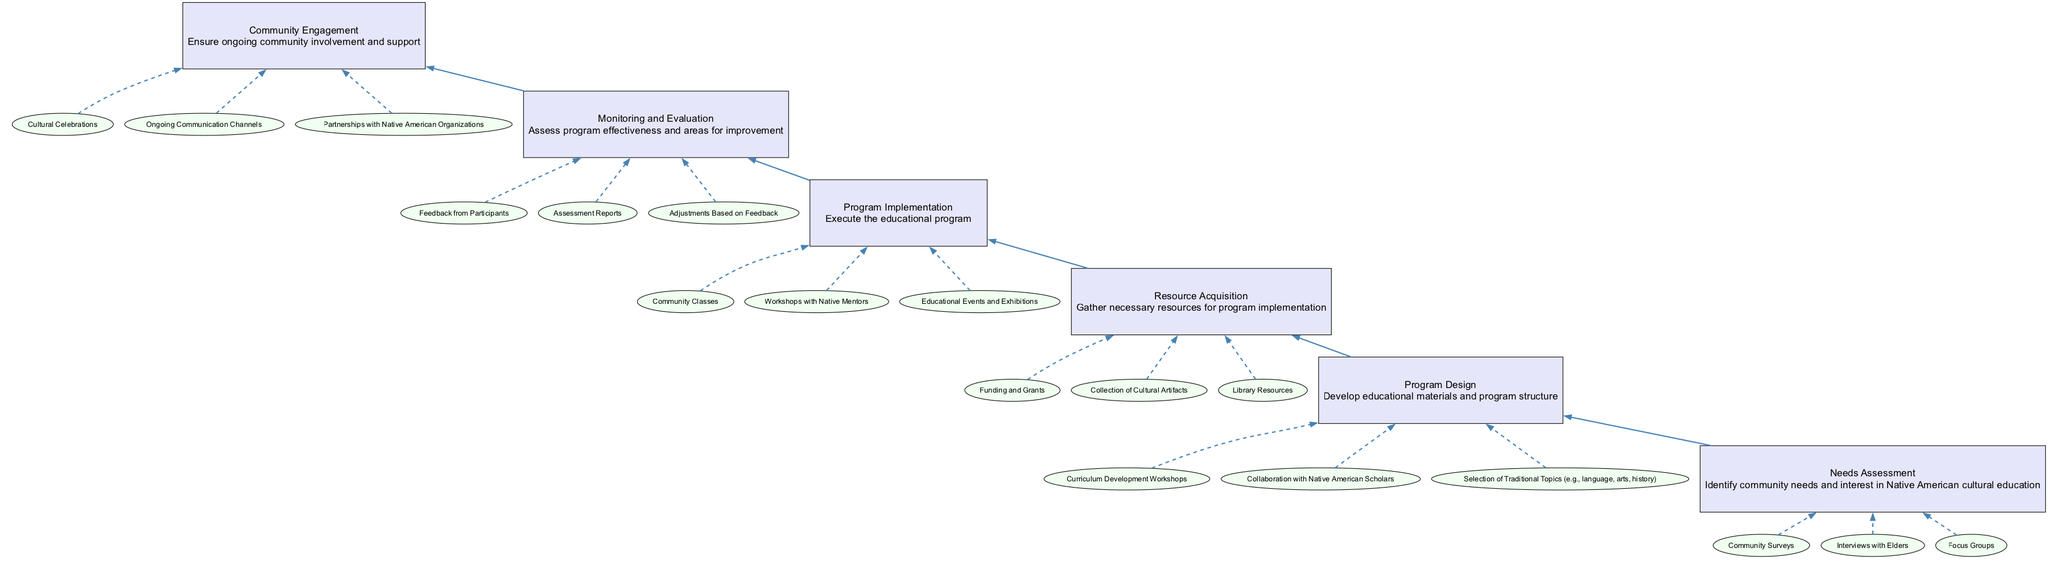What is the top node of the diagram? The top node of the diagram is labeled "Community Engagement," which signifies the final goal of the flow chart.
Answer: Community Engagement How many main nodes are there in the diagram? There are six main nodes, each representing a step in the process from "Needs Assessment" to "Community Engagement."
Answer: 6 What is the immediate predecessor of "Program Design"? The immediate predecessor of "Program Design" is "Needs Assessment," as it directly precedes it in the flow chart structure.
Answer: Needs Assessment Which entity is associated with "Program Implementation"? The entities listed under "Program Implementation" include "Community Classes," which is a key activity in this phase.
Answer: Community Classes What type of resources are gathered during "Resource Acquisition"? During "Resource Acquisition," the focus is on gathering specific types of resources such as "Funding and Grants," which are essential for the program's support.
Answer: Funding and Grants What is the last step in the flow chart? The last step in the flow chart is "Community Engagement," which emphasizes the importance of ongoing support from the community after the program implementation.
Answer: Community Engagement What is the relationship between "Monitoring and Evaluation" and "Program Implementation"? "Monitoring and Evaluation" follows "Program Implementation" and assesses the effectiveness of the executed educational program, indicating a causal relationship.
Answer: Causal relationship Which two nodes are connected directly by an edge? The nodes "Needs Assessment" and "Program Design" are connected directly by an edge, showing the flow from identifying needs to designing the program.
Answer: Needs Assessment and Program Design Which node involves feedback processes? The node "Monitoring and Evaluation" involves feedback processes, as it assesses feedback from participants to improve the program.
Answer: Monitoring and Evaluation 